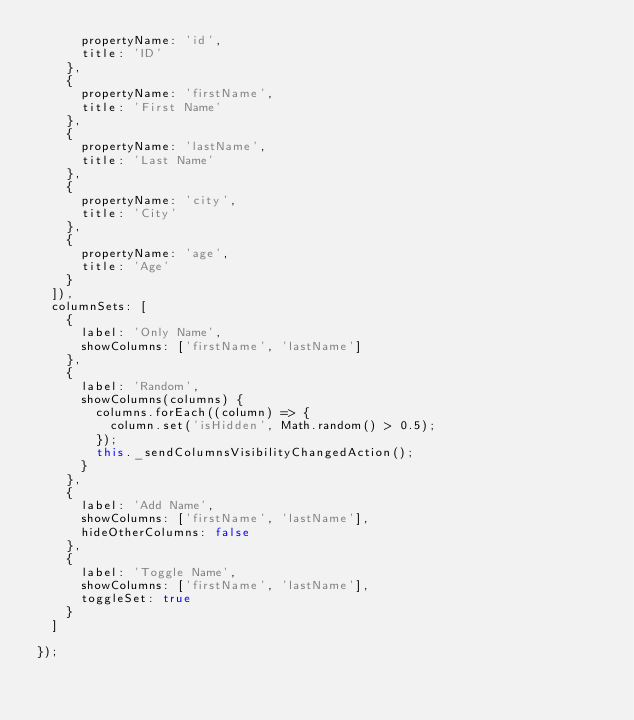Convert code to text. <code><loc_0><loc_0><loc_500><loc_500><_JavaScript_>      propertyName: 'id',
      title: 'ID'
    },
    {
      propertyName: 'firstName',
      title: 'First Name'
    },
    {
      propertyName: 'lastName',
      title: 'Last Name'
    },
    {
      propertyName: 'city',
      title: 'City'
    },
    {
      propertyName: 'age',
      title: 'Age'
    }
  ]),
  columnSets: [
    {
      label: 'Only Name',
      showColumns: ['firstName', 'lastName']
    },
    {
      label: 'Random',
      showColumns(columns) {
        columns.forEach((column) => {
          column.set('isHidden', Math.random() > 0.5);
        });
        this._sendColumnsVisibilityChangedAction();
      }
    },
    {
      label: 'Add Name',
      showColumns: ['firstName', 'lastName'],
      hideOtherColumns: false
    },
    {
      label: 'Toggle Name',
      showColumns: ['firstName', 'lastName'],
      toggleSet: true
    }
  ]

});
</code> 